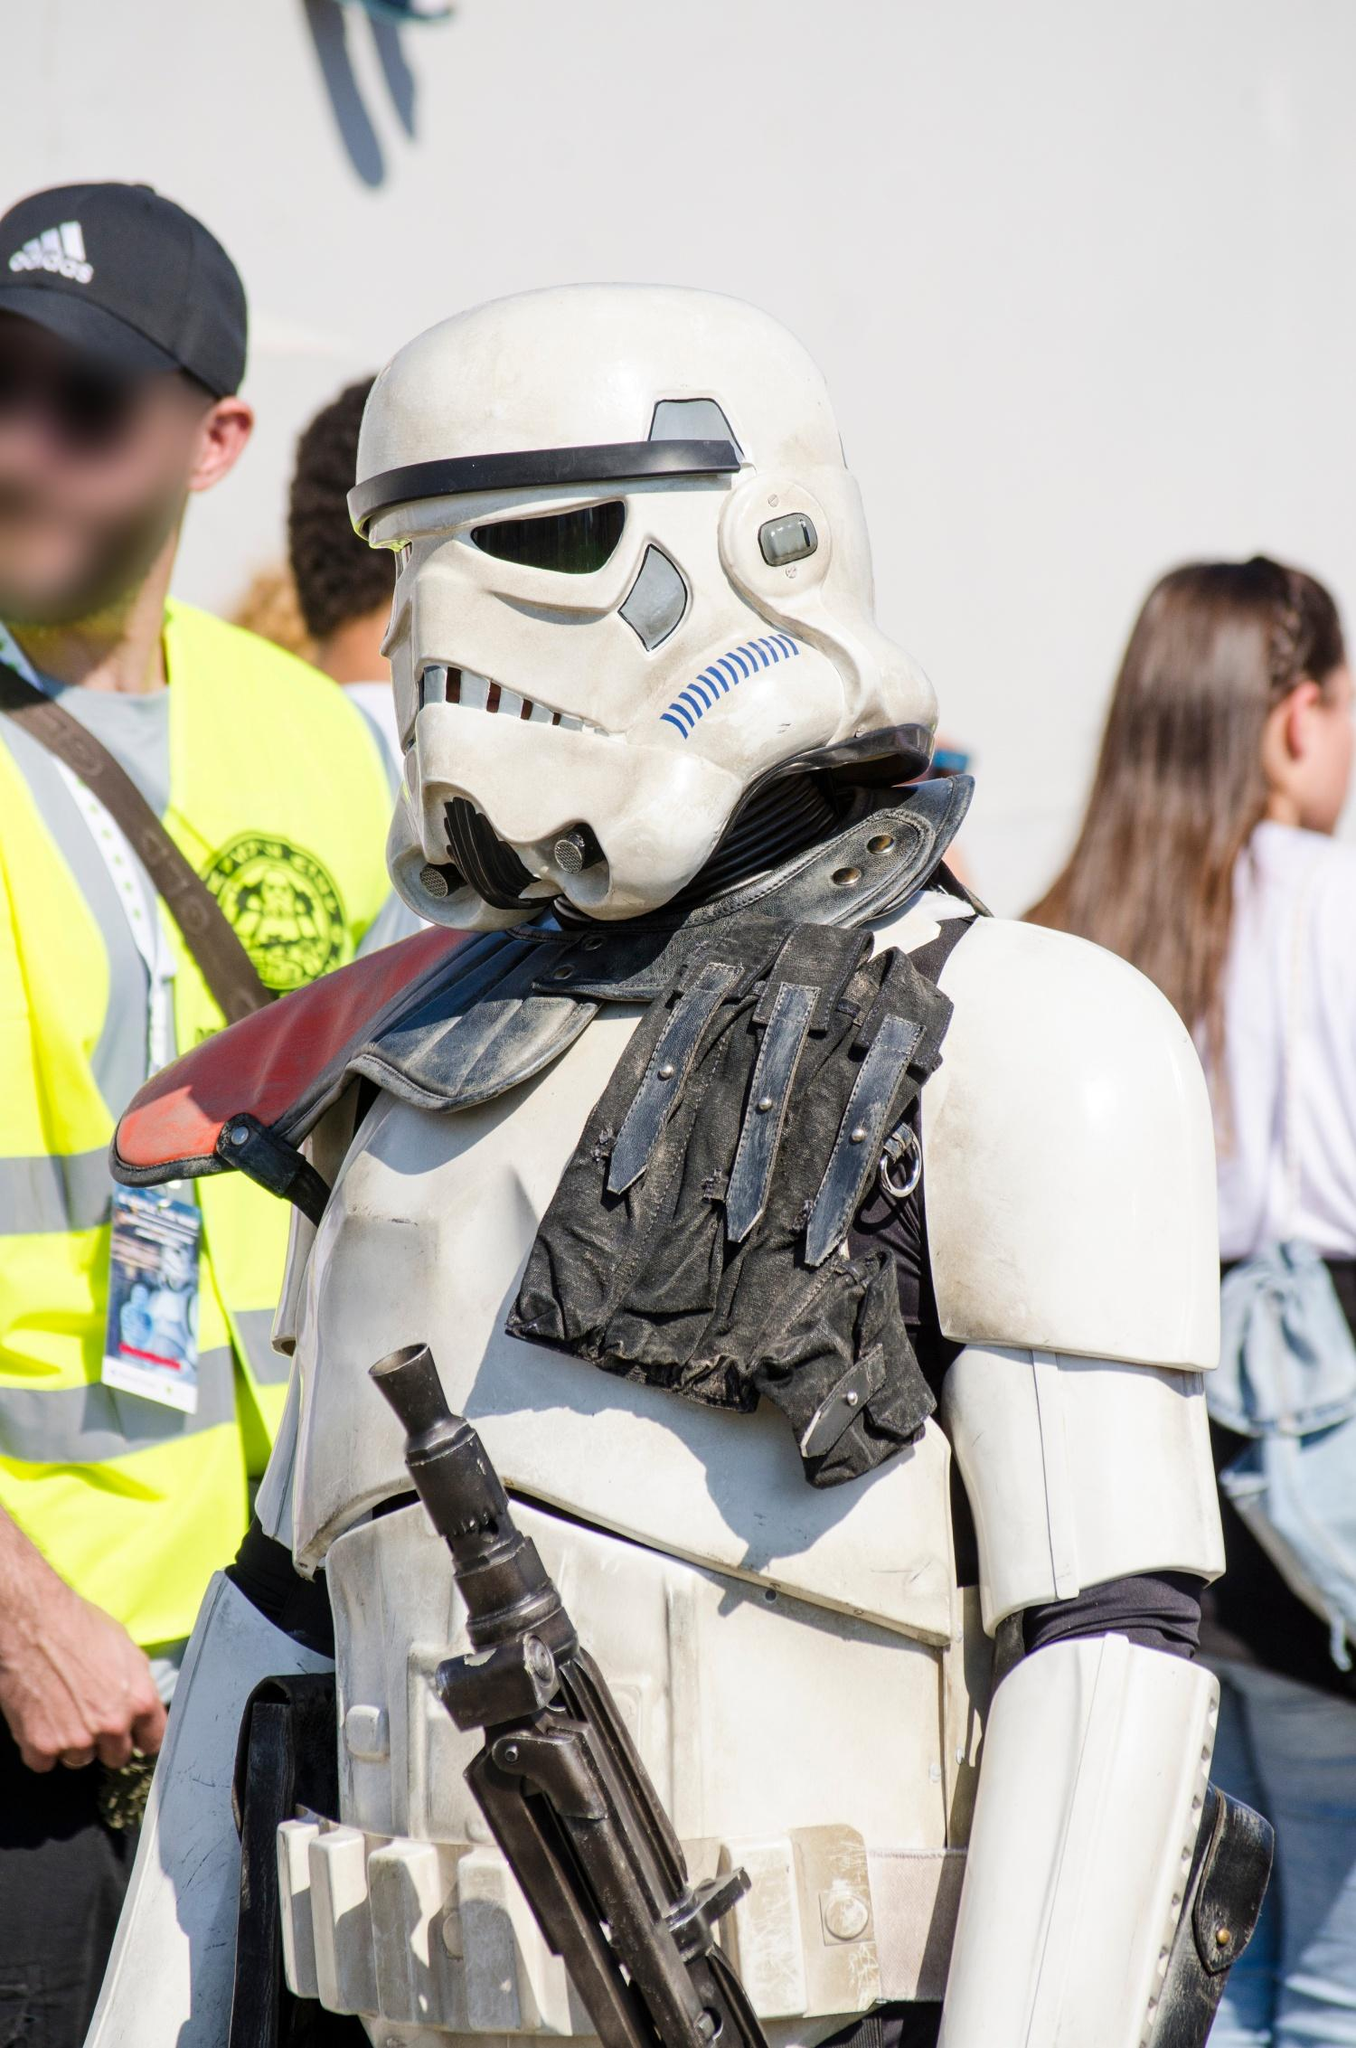If the Stormtrooper costume came to life and stepped out of the image, what do you think it would say? If the Stormtrooper costume magically came to life and stepped out of the image, it might straighten its posture, look around with vigilant eyes, and say in a stern, authoritative voice, "Reporting for duty, Commander. Awaiting further orders." 